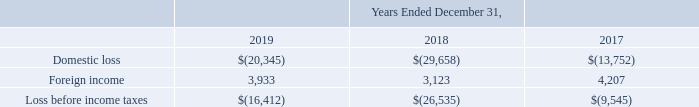11. Income Taxes
The geographical breakdown of loss before income taxes is as follows (in thousands):
What is the company's domestic loss in 2019?
Answer scale should be: thousand. $(20,345). What is the company's domestic loss in 2018?
Answer scale should be: thousand. $(29,658). What is the company's domestic loss in 2017?
Answer scale should be: thousand. $(13,752). What is the company's total loss before income taxes between 2017 to 2019?
Answer scale should be: thousand. $(16,412) + $(26,535) + $(9,545)
Answer: -52492. What is the company's change in foreign income between 2018 and 2019?
Answer scale should be: percent. (3,933 - 3,123)/3,123 
Answer: 25.94. What is the company's total domestic loss between 2017 to 2019?
Answer scale should be: thousand. $(20,345) + $(29,658) + $(13,752) 
Answer: -63755. 